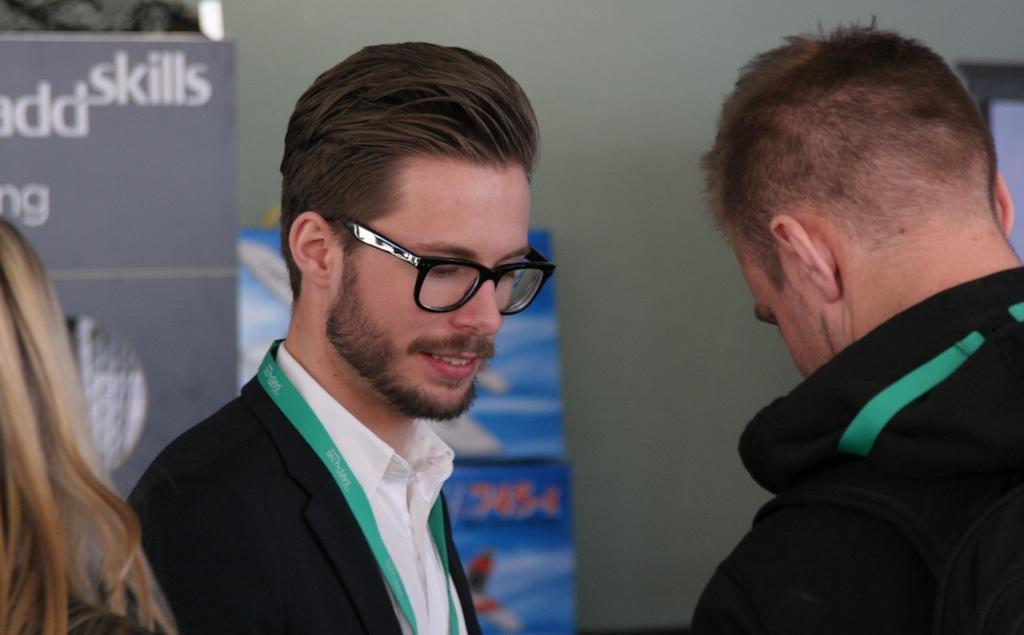In one or two sentences, can you explain what this image depicts? In this image we can see two persons and on the left side we can see the hair of a person. In the background there are hoardings and wall. 